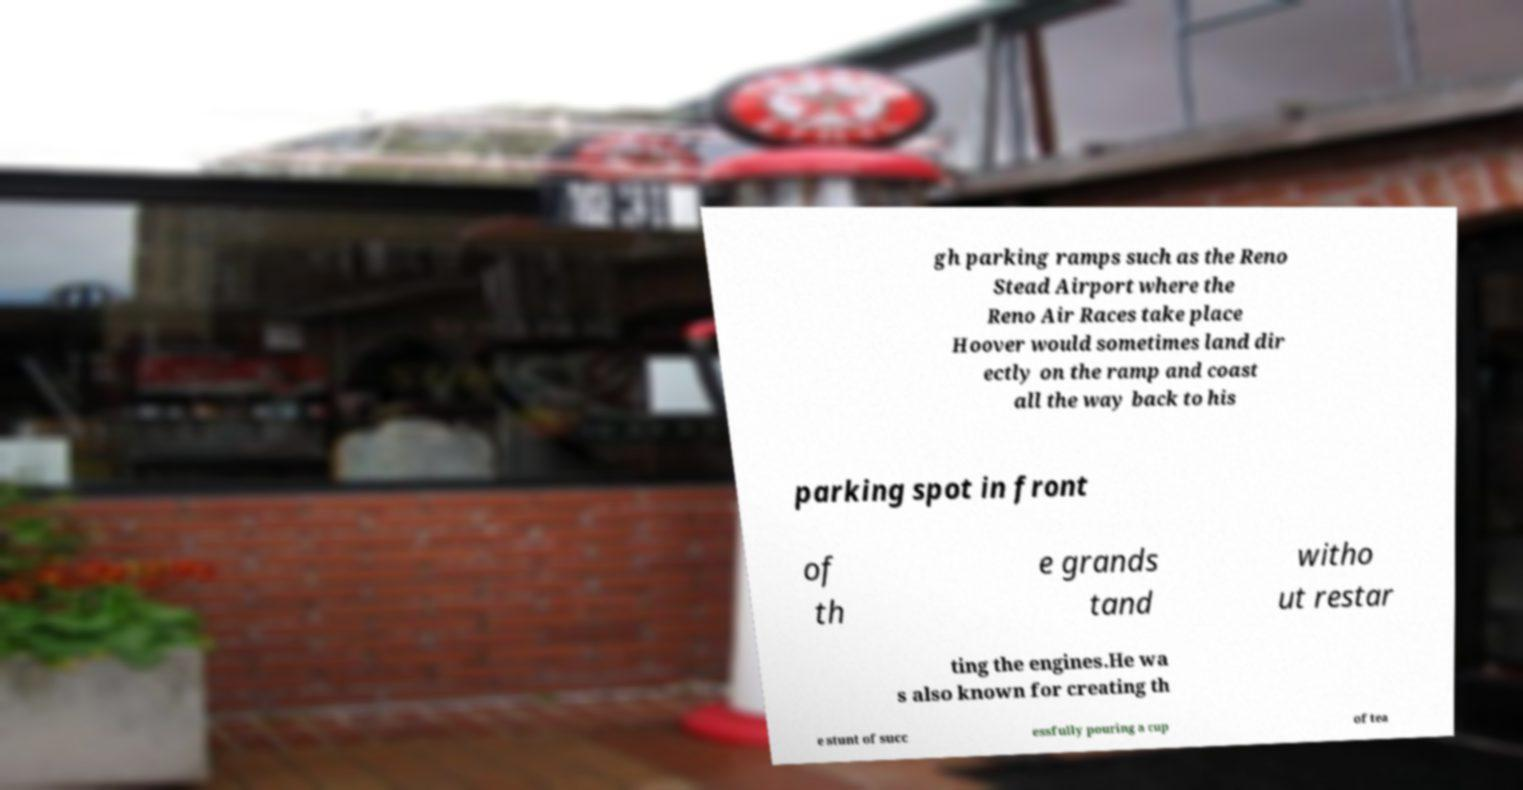There's text embedded in this image that I need extracted. Can you transcribe it verbatim? gh parking ramps such as the Reno Stead Airport where the Reno Air Races take place Hoover would sometimes land dir ectly on the ramp and coast all the way back to his parking spot in front of th e grands tand witho ut restar ting the engines.He wa s also known for creating th e stunt of succ essfully pouring a cup of tea 